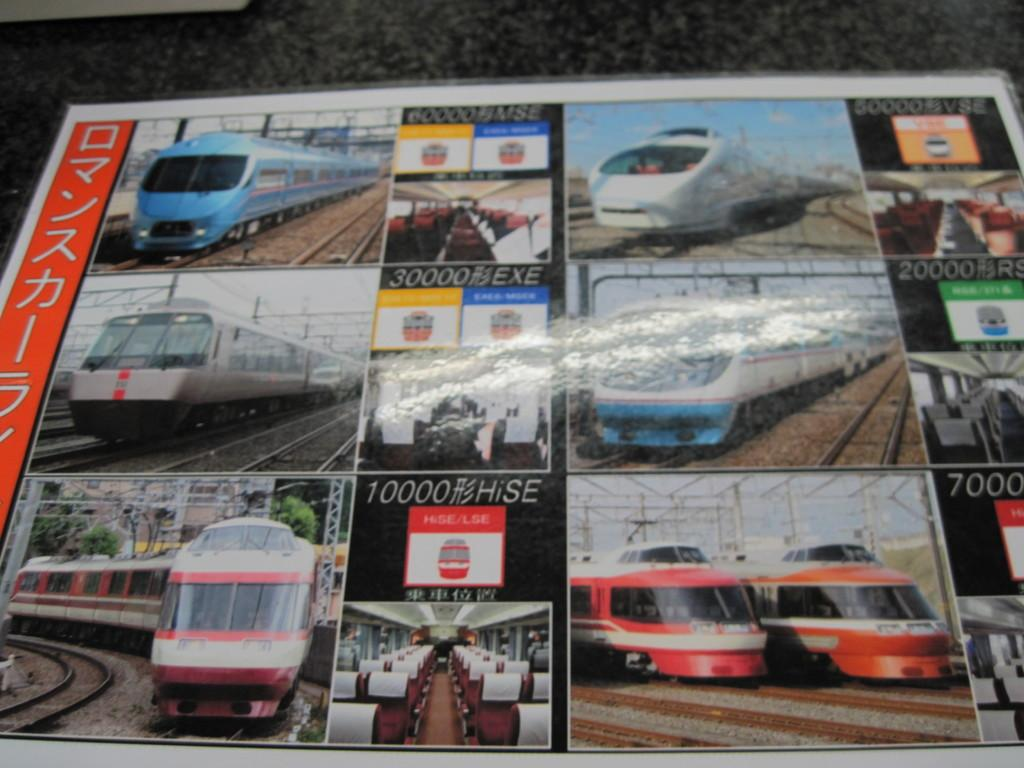What is the main subject of the image? The main subject of the image is a chart. What type of content is featured on the chart? The chart contains pictures of trains. Can you tell me how many train tickets are shown on the chart? There is no mention of train tickets on the chart; it only contains pictures of trains. What type of pigs can be seen interacting with the trains on the chart? There are no pigs present on the chart; it only features pictures of trains. 